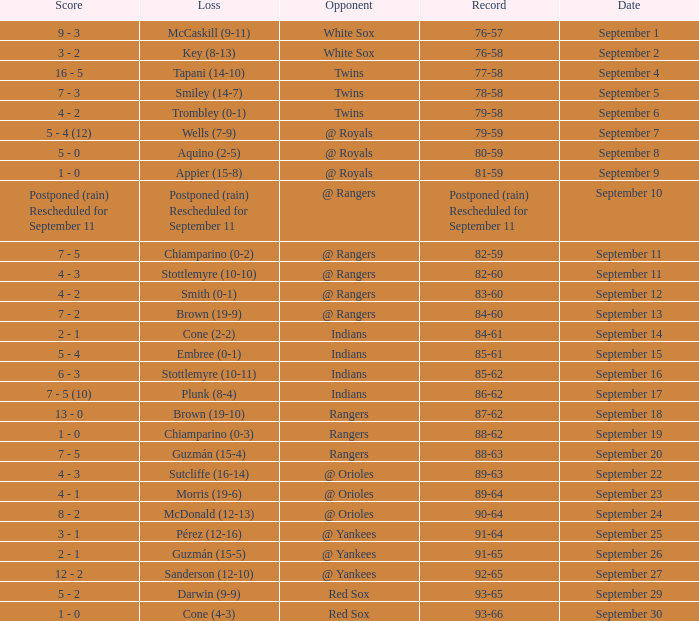What does the loss amount to on september 16? Stottlemyre (10-11). 